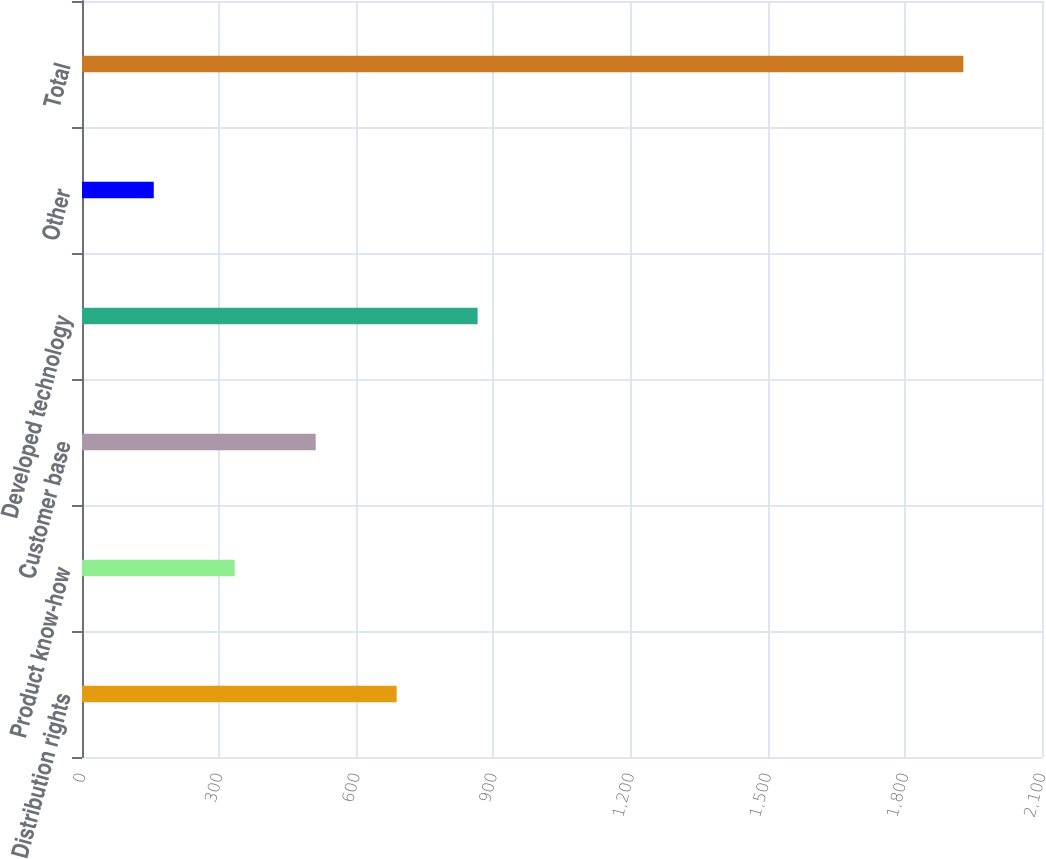Convert chart. <chart><loc_0><loc_0><loc_500><loc_500><bar_chart><fcel>Distribution rights<fcel>Product know-how<fcel>Customer base<fcel>Developed technology<fcel>Other<fcel>Total<nl><fcel>688.3<fcel>334.1<fcel>511.2<fcel>865.4<fcel>157<fcel>1928<nl></chart> 